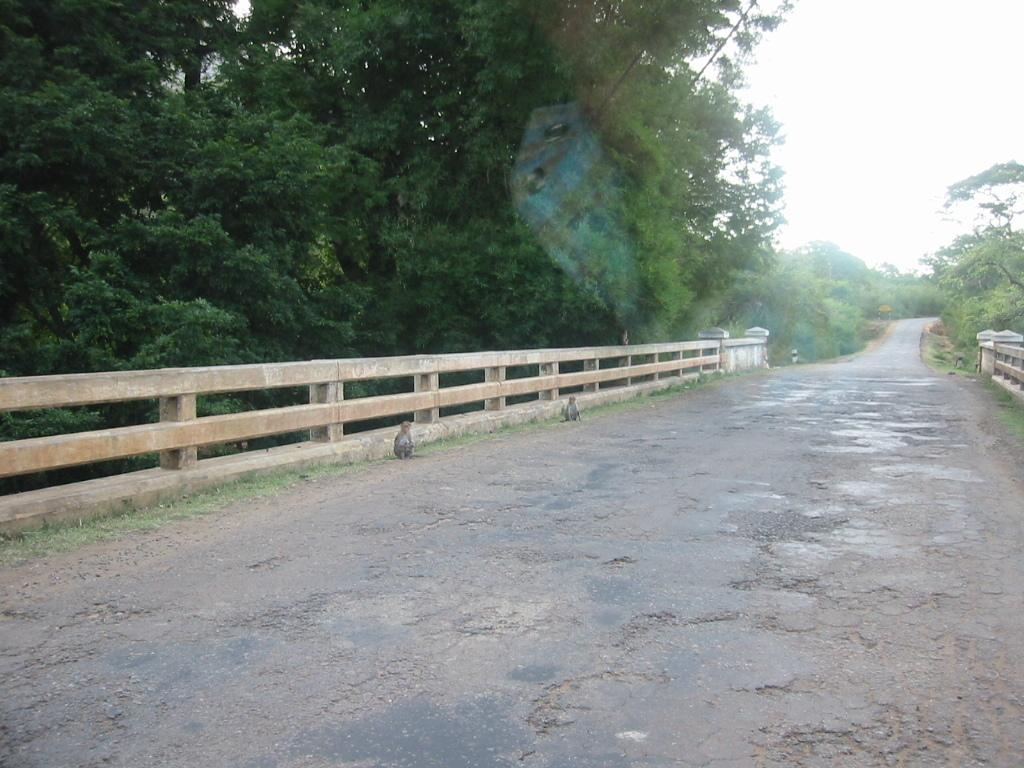What is the main feature of the image? There is a road in the image. What animals can be seen in the image? There are monkeys in the image. What type of vegetation is present in the image? There is grass in the image, as well as trees. What structures can be seen in the image? There are railings in the image. What can be seen in the background of the image? The sky is visible in the background of the image. What flavor of whip is being consumed by the monkeys in the image? There is no whip present in the image, and therefore no flavor can be determined. Are the monkeys wearing masks in the image? There is no indication in the image that the monkeys are wearing masks. 